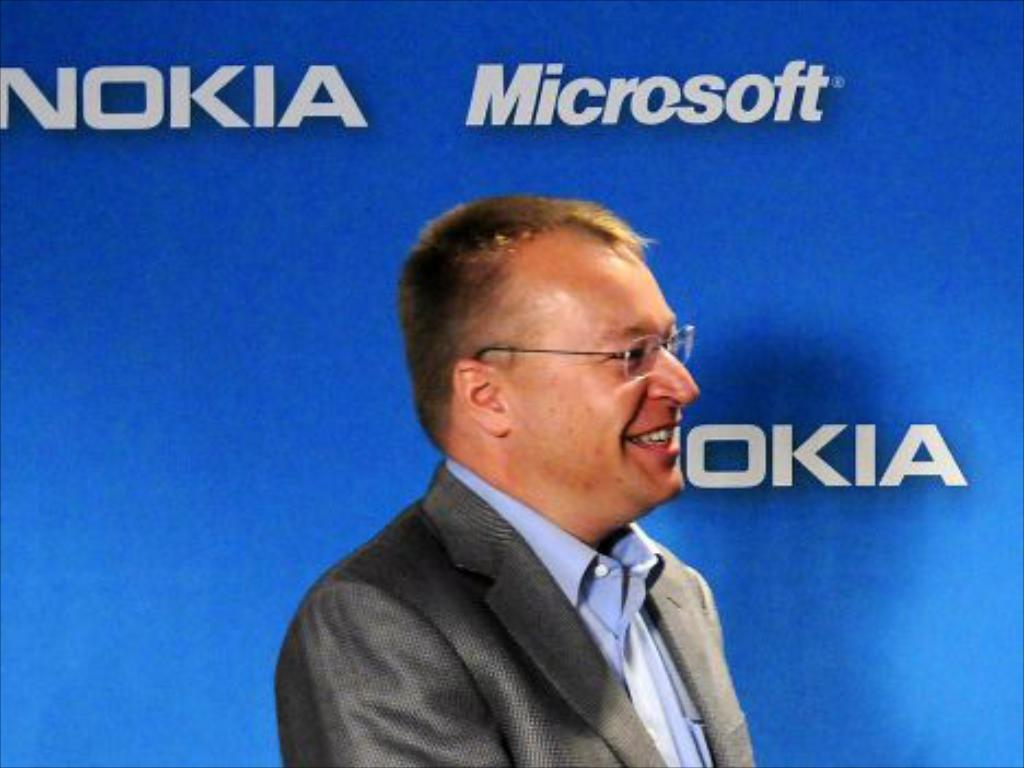Provide a one-sentence caption for the provided image. A man stands in front of a blue board with Nokia and Microsoft Printed on it. 